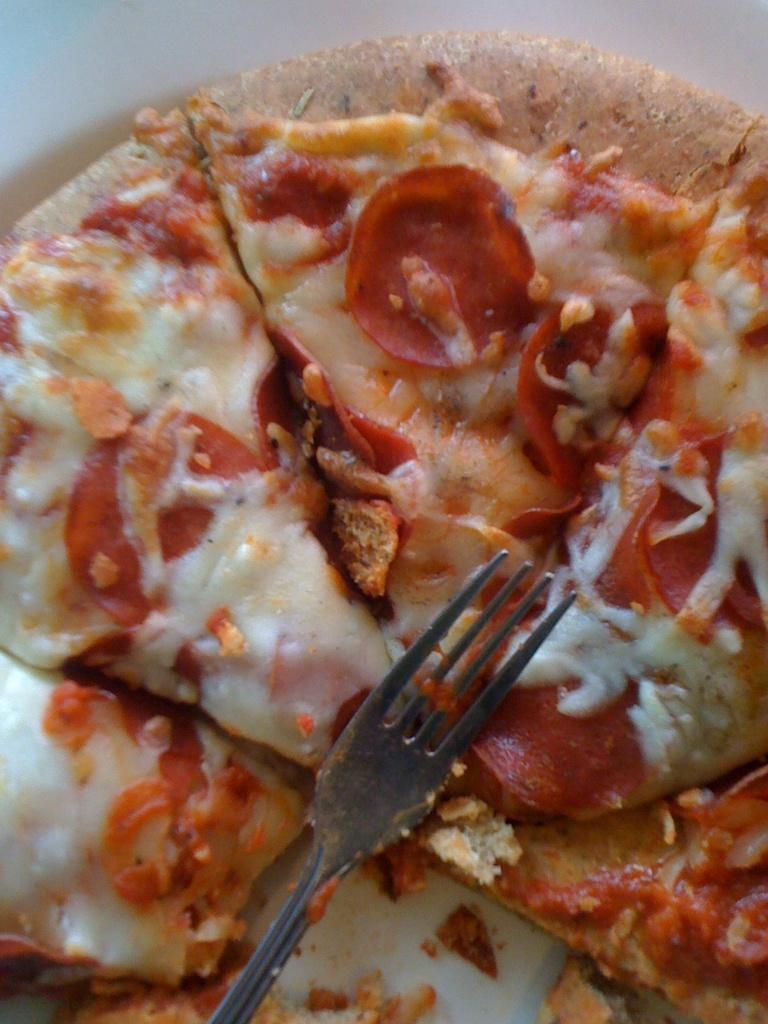What utensil can be seen on the pizza in the image? There is a fork on the pizza in the image. What type of veil is draped over the cart in the image? There is no veil or cart present in the image; it only features a pizza with a fork on it. 